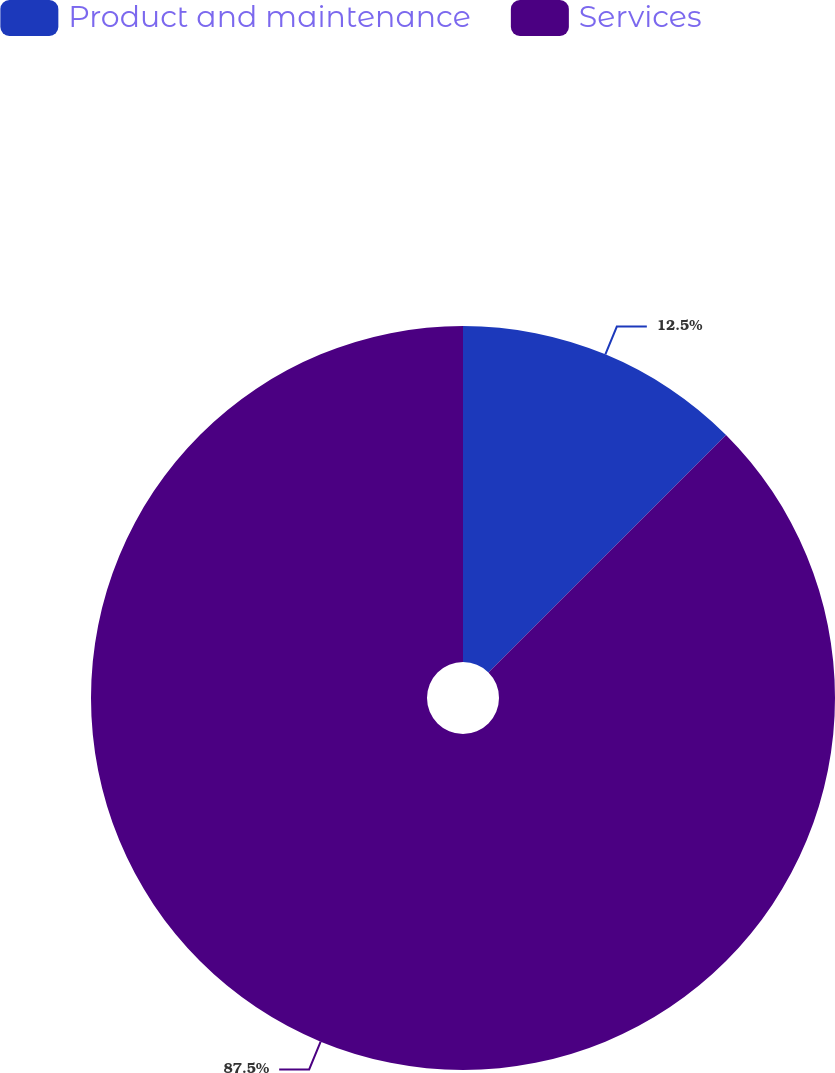<chart> <loc_0><loc_0><loc_500><loc_500><pie_chart><fcel>Product and maintenance<fcel>Services<nl><fcel>12.5%<fcel>87.5%<nl></chart> 